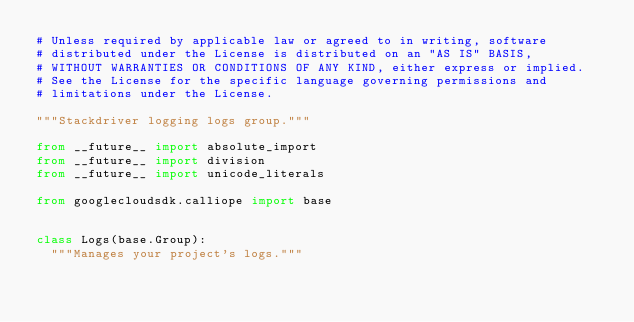Convert code to text. <code><loc_0><loc_0><loc_500><loc_500><_Python_># Unless required by applicable law or agreed to in writing, software
# distributed under the License is distributed on an "AS IS" BASIS,
# WITHOUT WARRANTIES OR CONDITIONS OF ANY KIND, either express or implied.
# See the License for the specific language governing permissions and
# limitations under the License.

"""Stackdriver logging logs group."""

from __future__ import absolute_import
from __future__ import division
from __future__ import unicode_literals

from googlecloudsdk.calliope import base


class Logs(base.Group):
  """Manages your project's logs."""
</code> 